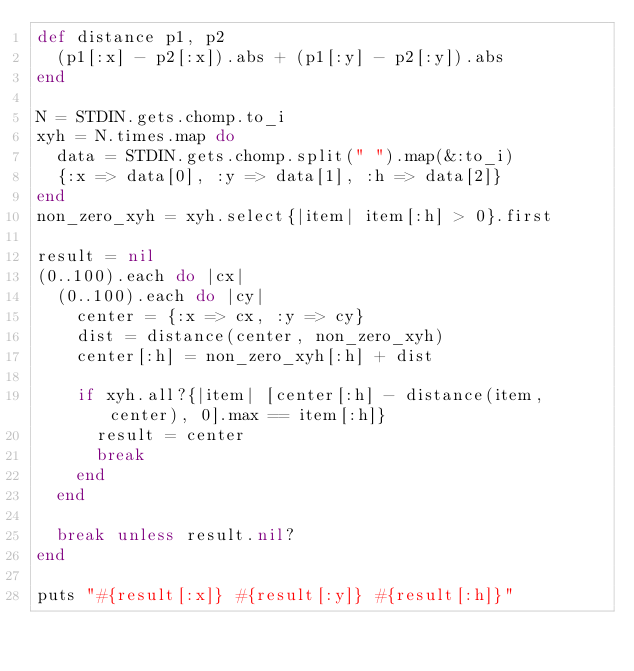Convert code to text. <code><loc_0><loc_0><loc_500><loc_500><_Ruby_>def distance p1, p2
  (p1[:x] - p2[:x]).abs + (p1[:y] - p2[:y]).abs
end

N = STDIN.gets.chomp.to_i
xyh = N.times.map do 
  data = STDIN.gets.chomp.split(" ").map(&:to_i)
  {:x => data[0], :y => data[1], :h => data[2]}
end
non_zero_xyh = xyh.select{|item| item[:h] > 0}.first

result = nil
(0..100).each do |cx|
  (0..100).each do |cy|
    center = {:x => cx, :y => cy}
    dist = distance(center, non_zero_xyh)
    center[:h] = non_zero_xyh[:h] + dist

    if xyh.all?{|item| [center[:h] - distance(item, center), 0].max == item[:h]}
      result = center
      break
    end
  end

  break unless result.nil?
end

puts "#{result[:x]} #{result[:y]} #{result[:h]}"
</code> 